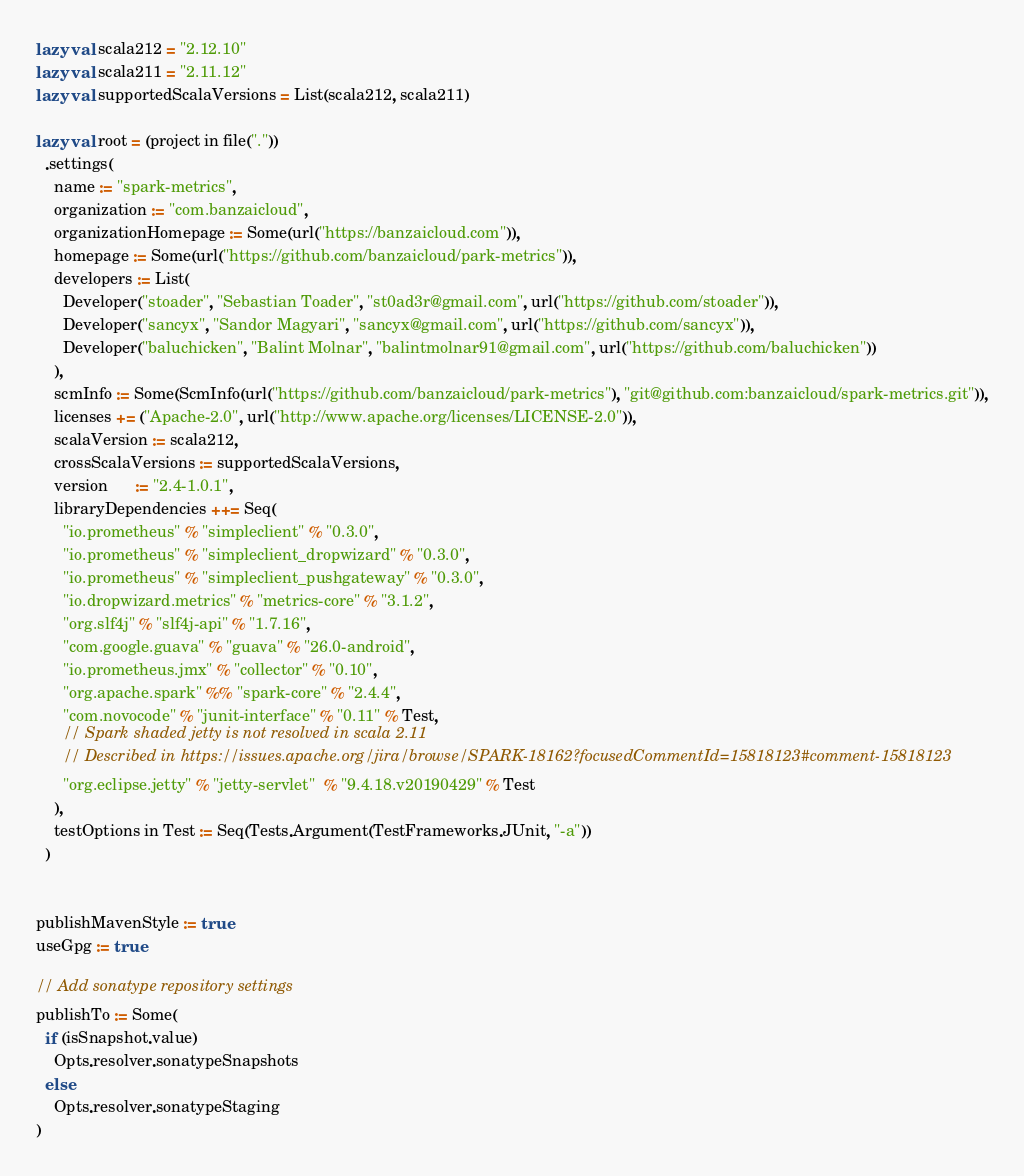Convert code to text. <code><loc_0><loc_0><loc_500><loc_500><_Scala_>lazy val scala212 = "2.12.10"
lazy val scala211 = "2.11.12"
lazy val supportedScalaVersions = List(scala212, scala211)

lazy val root = (project in file("."))
  .settings(
    name := "spark-metrics",
    organization := "com.banzaicloud",
    organizationHomepage := Some(url("https://banzaicloud.com")),
    homepage := Some(url("https://github.com/banzaicloud/park-metrics")),
    developers := List(
      Developer("stoader", "Sebastian Toader", "st0ad3r@gmail.com", url("https://github.com/stoader")),
      Developer("sancyx", "Sandor Magyari", "sancyx@gmail.com", url("https://github.com/sancyx")),
      Developer("baluchicken", "Balint Molnar", "balintmolnar91@gmail.com", url("https://github.com/baluchicken"))
    ),
    scmInfo := Some(ScmInfo(url("https://github.com/banzaicloud/park-metrics"), "git@github.com:banzaicloud/spark-metrics.git")),
    licenses += ("Apache-2.0", url("http://www.apache.org/licenses/LICENSE-2.0")),
    scalaVersion := scala212,
    crossScalaVersions := supportedScalaVersions,
    version      := "2.4-1.0.1",
    libraryDependencies ++= Seq(
      "io.prometheus" % "simpleclient" % "0.3.0",
      "io.prometheus" % "simpleclient_dropwizard" % "0.3.0",
      "io.prometheus" % "simpleclient_pushgateway" % "0.3.0",
      "io.dropwizard.metrics" % "metrics-core" % "3.1.2",
      "org.slf4j" % "slf4j-api" % "1.7.16",
      "com.google.guava" % "guava" % "26.0-android",
      "io.prometheus.jmx" % "collector" % "0.10",
      "org.apache.spark" %% "spark-core" % "2.4.4",
      "com.novocode" % "junit-interface" % "0.11" % Test,
      // Spark shaded jetty is not resolved in scala 2.11
      // Described in https://issues.apache.org/jira/browse/SPARK-18162?focusedCommentId=15818123#comment-15818123
      "org.eclipse.jetty" % "jetty-servlet"  % "9.4.18.v20190429" % Test
    ),
    testOptions in Test := Seq(Tests.Argument(TestFrameworks.JUnit, "-a"))
  )


publishMavenStyle := true
useGpg := true

// Add sonatype repository settings
publishTo := Some(
  if (isSnapshot.value)
    Opts.resolver.sonatypeSnapshots
  else
    Opts.resolver.sonatypeStaging
)

</code> 